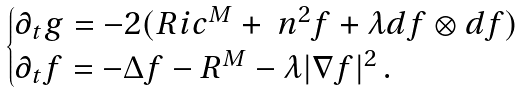<formula> <loc_0><loc_0><loc_500><loc_500>\begin{cases} \partial _ { t } g = - 2 ( R i c ^ { M } + \ n ^ { 2 } f + \lambda d f \otimes d f ) \\ \partial _ { t } f = - \Delta f - R ^ { M } - \lambda | \nabla f | ^ { 2 } \, . \end{cases}</formula> 